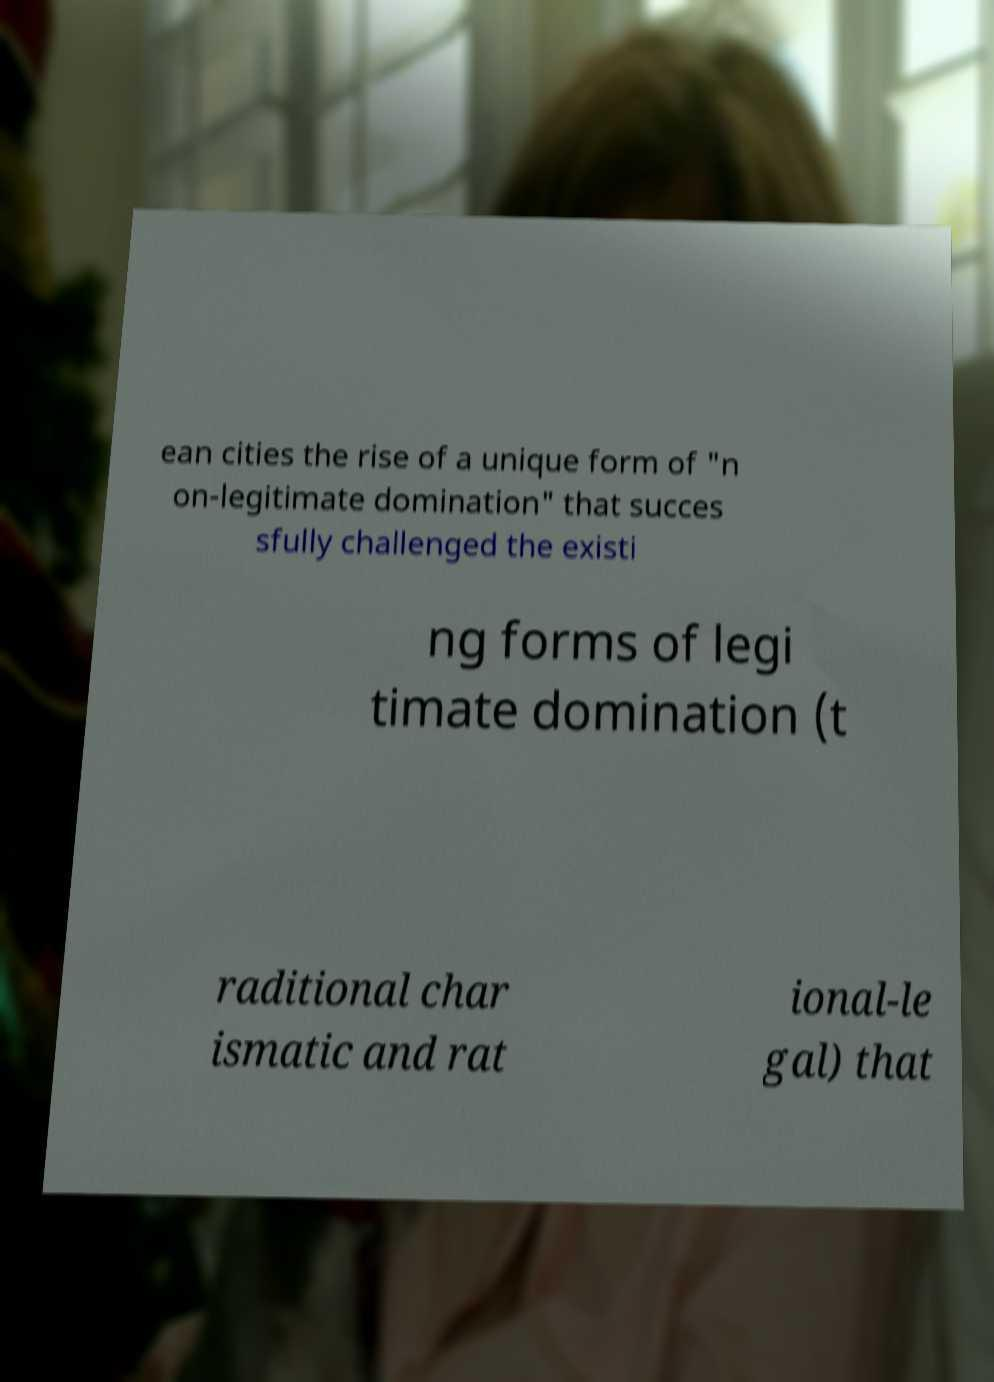What messages or text are displayed in this image? I need them in a readable, typed format. ean cities the rise of a unique form of "n on-legitimate domination" that succes sfully challenged the existi ng forms of legi timate domination (t raditional char ismatic and rat ional-le gal) that 